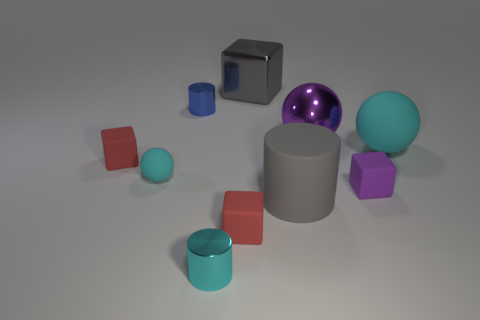How many objects are red matte things that are to the left of the cyan metal thing or large spheres?
Offer a terse response. 3. Are there more tiny objects that are to the left of the blue metal thing than tiny balls that are to the right of the gray shiny object?
Offer a terse response. Yes. Do the large purple thing and the large cube have the same material?
Offer a terse response. Yes. What shape is the matte object that is left of the big gray matte cylinder and in front of the purple rubber block?
Provide a short and direct response. Cube. There is a cyan object that is the same material as the blue object; what is its shape?
Give a very brief answer. Cylinder. Is there a tiny red metal cylinder?
Give a very brief answer. No. There is a matte sphere that is left of the large cyan matte object; is there a cyan rubber sphere that is in front of it?
Your answer should be very brief. No. There is a gray thing that is the same shape as the tiny purple matte object; what material is it?
Provide a short and direct response. Metal. Are there more big blocks than big green rubber balls?
Provide a succinct answer. Yes. Is the color of the metallic ball the same as the metallic cylinder to the right of the small blue object?
Provide a short and direct response. No. 